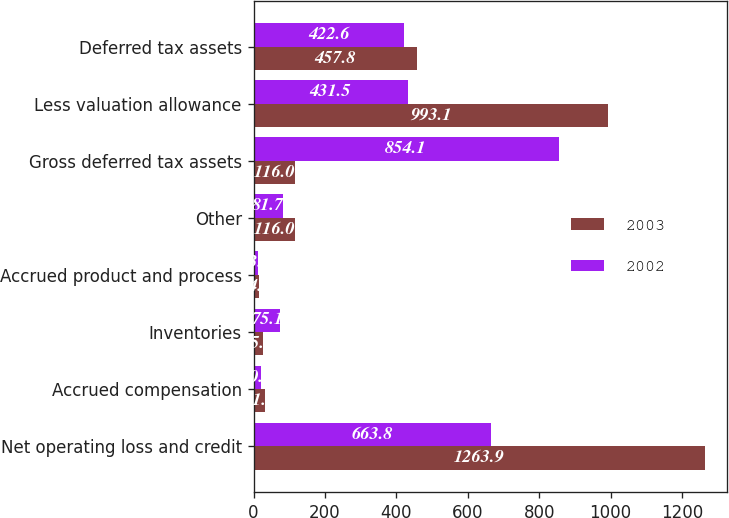Convert chart to OTSL. <chart><loc_0><loc_0><loc_500><loc_500><stacked_bar_chart><ecel><fcel>Net operating loss and credit<fcel>Accrued compensation<fcel>Inventories<fcel>Accrued product and process<fcel>Other<fcel>Gross deferred tax assets<fcel>Less valuation allowance<fcel>Deferred tax assets<nl><fcel>2003<fcel>1263.9<fcel>31.2<fcel>25.2<fcel>14.6<fcel>116<fcel>116<fcel>993.1<fcel>457.8<nl><fcel>2002<fcel>663.8<fcel>20.4<fcel>75.1<fcel>13.1<fcel>81.7<fcel>854.1<fcel>431.5<fcel>422.6<nl></chart> 